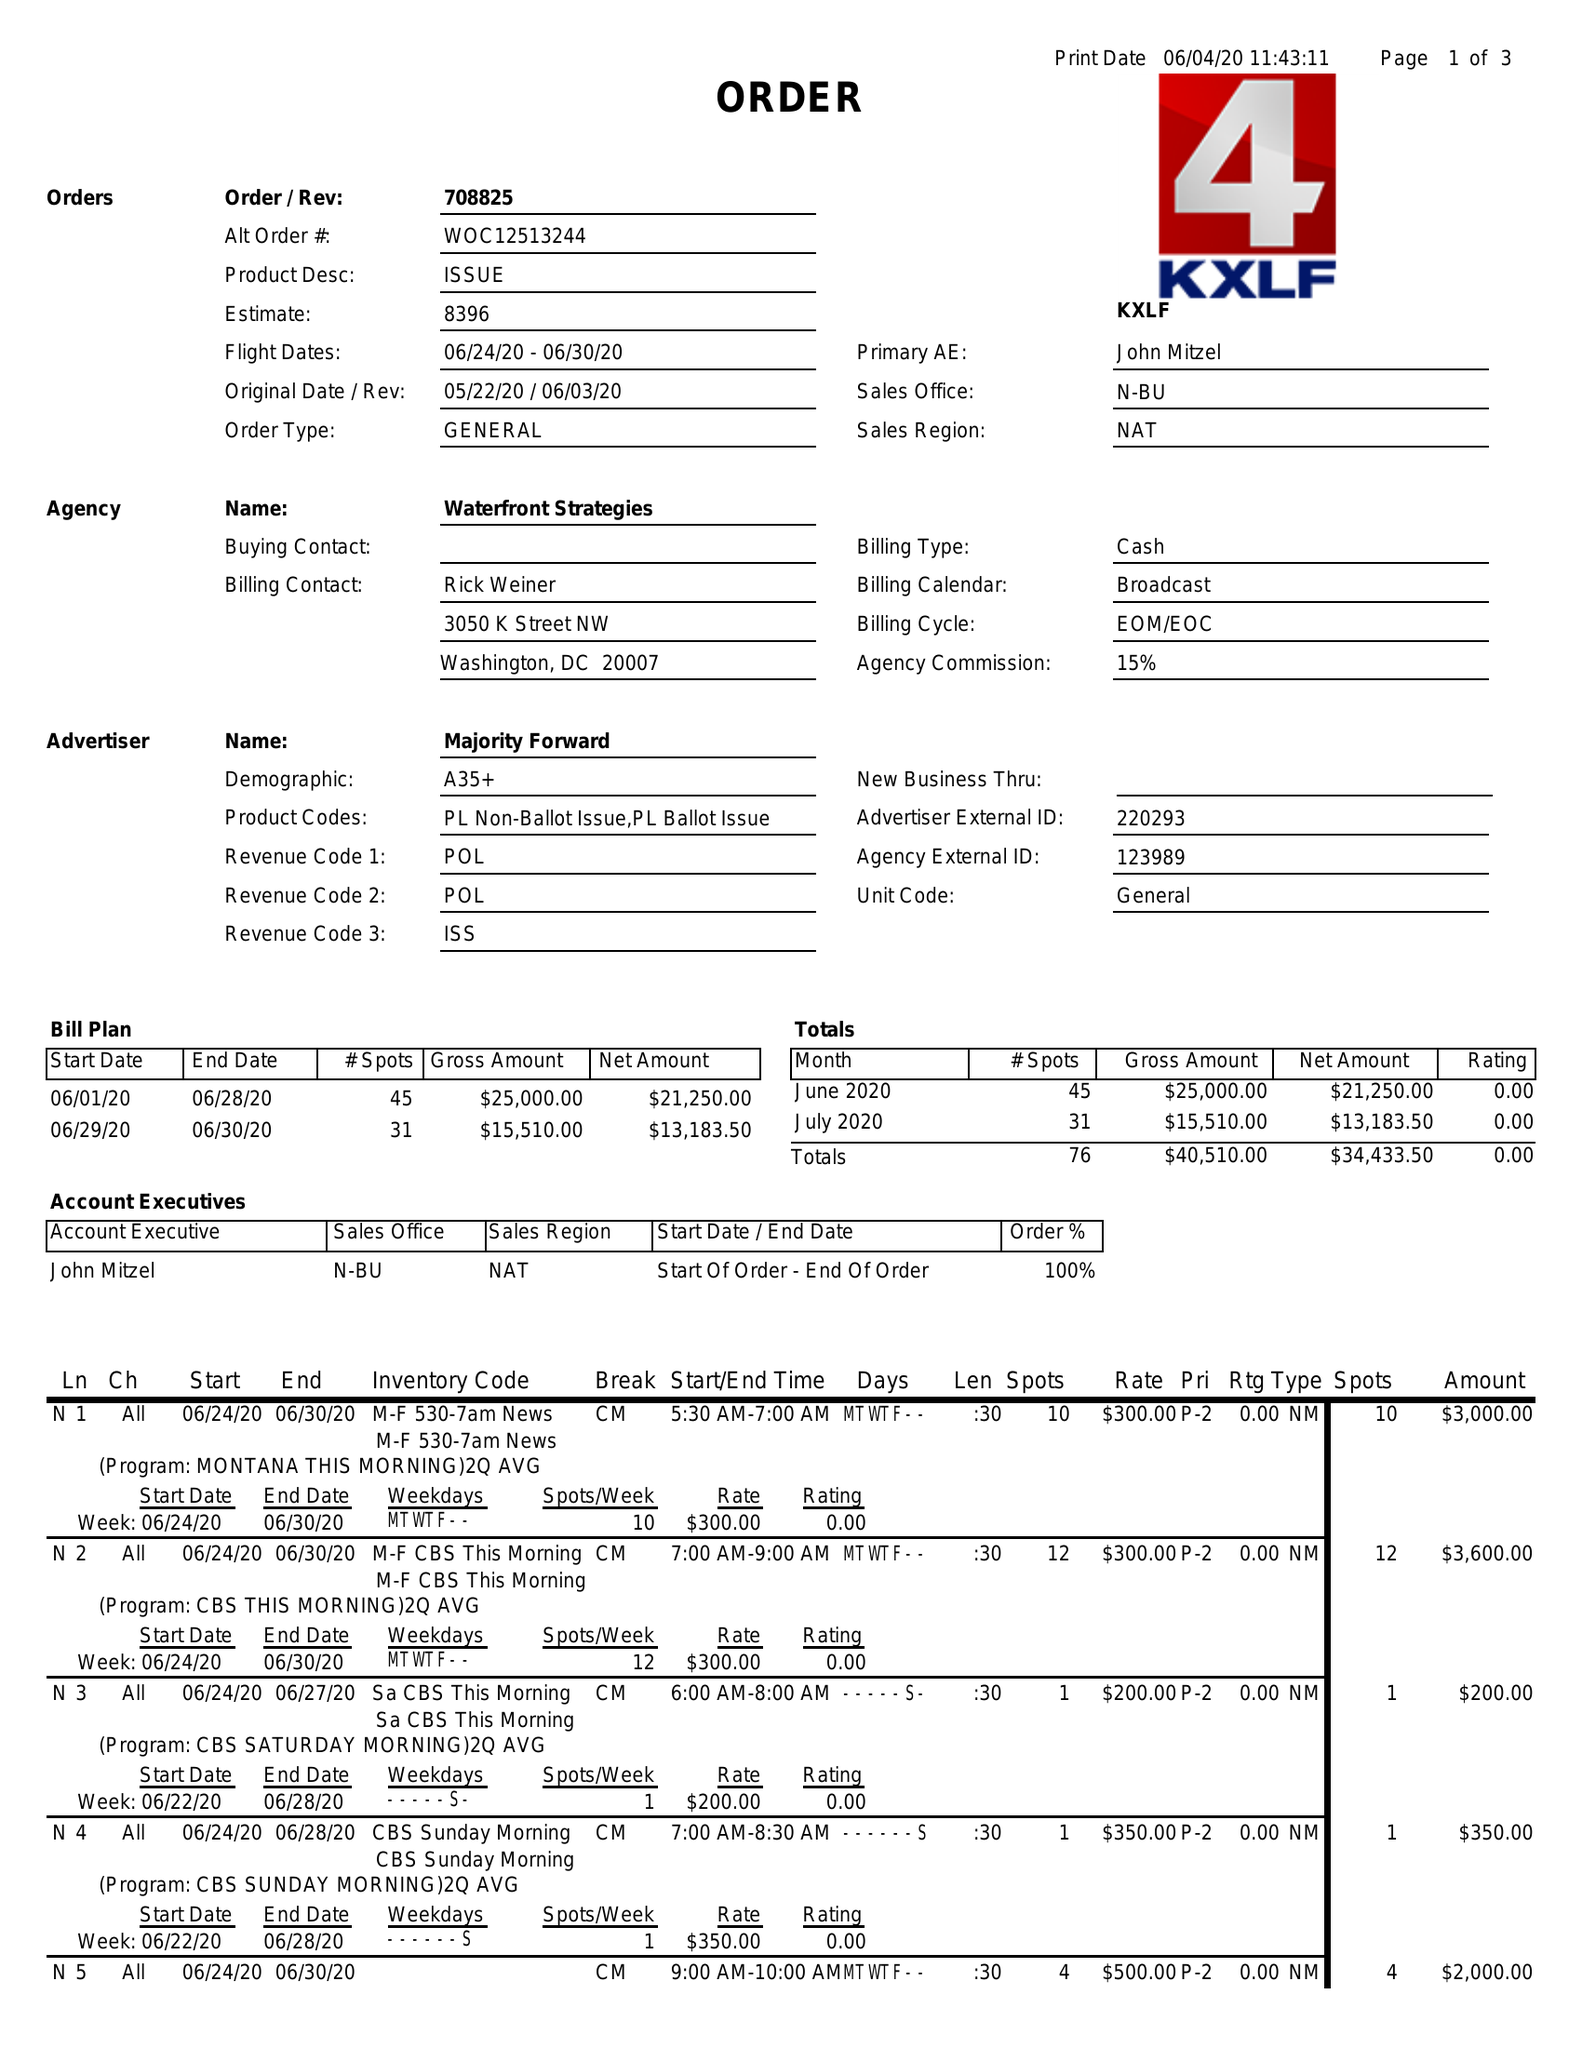What is the value for the advertiser?
Answer the question using a single word or phrase. MAJORITY FORWARD 